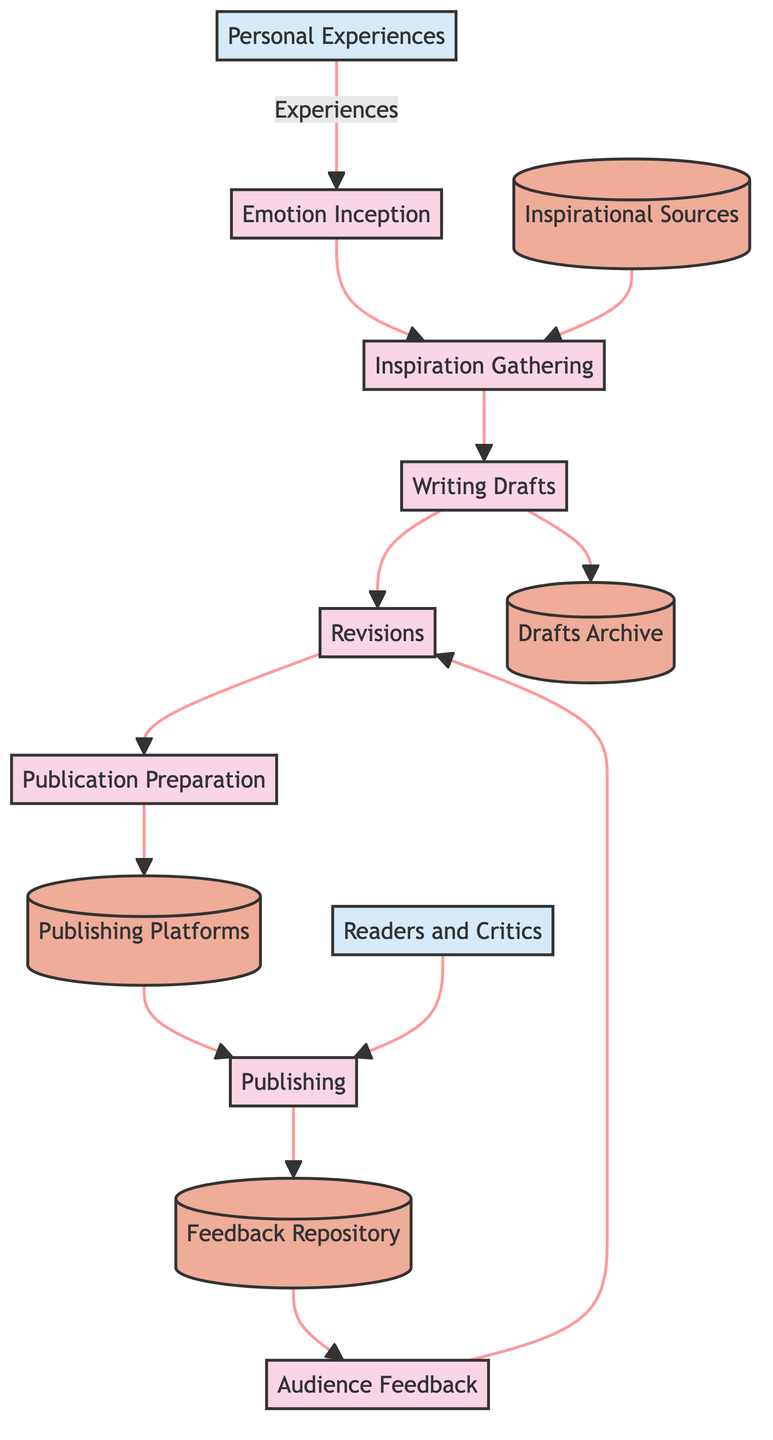What initiates the poem writing process? The process begins with "Emotion Inception," which is derived from personal experiences and the sorrow of conflict, indicating that these emotions are the spark for creating poetry.
Answer: Emotion Inception How many main processes are there in the diagram? The diagram outlines seven main processes, ranging from "Emotion Inception" to "Audience Feedback," which details the entire creative writing workflow.
Answer: Seven What follows "Inspiration Gathering" in the flow? After "Inspiration Gathering," the subsequent step is "Writing Drafts," demonstrating the transformation of gathered inspirations into the initial drafts of the poem.
Answer: Writing Drafts Which data store holds the various drafts of the poem? The "Drafts Archive" is the specific data store where different stages of poem drafts are saved, reflecting the iterative nature of writing and revision.
Answer: Drafts Archive How is audience feedback incorporated into the creative process? Audience feedback, obtained after the poem's publication, directly influences subsequent revisions of the poem, highlighting the connection between reader response and the revision process.
Answer: Revisions Which external entities are involved in the diagram? The external entities are "Personal Experiences" and "Readers and Critics," which feed into and interact with the main creative processes regarding emotion and feedback.
Answer: Personal Experiences, Readers and Critics What is the final process in this diagram? The last process in this data flow diagram is "Audience Feedback," which concludes the cycle by analyzing reader responses and critiques after the poem is published.
Answer: Audience Feedback What type of platforms are used for publishing? The diagram specifies "Publishing Platforms" as the data store which includes literary magazines, social media, and personal blogs for poem publication.
Answer: Publishing Platforms How does the process of writing drafts relate to inspiration? The "Writing Drafts" process is directly initiated by "Inspiration Gathering," meaning that the inspirations collected are essential to the initial creation of the poem drafts.
Answer: Writing Drafts How does feedback influence the revision process? Feedback collected from the "Feedback Repository" informs the "Revisions" process, indicating that critiques and responses lead to changes in future drafts of the poem.
Answer: Revisions 